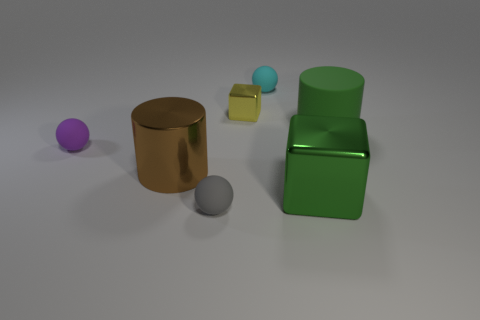Add 1 big green cylinders. How many objects exist? 8 Subtract all cylinders. How many objects are left? 5 Add 4 tiny cyan rubber things. How many tiny cyan rubber things are left? 5 Add 3 tiny rubber objects. How many tiny rubber objects exist? 6 Subtract 0 red balls. How many objects are left? 7 Subtract all large red metal blocks. Subtract all green rubber objects. How many objects are left? 6 